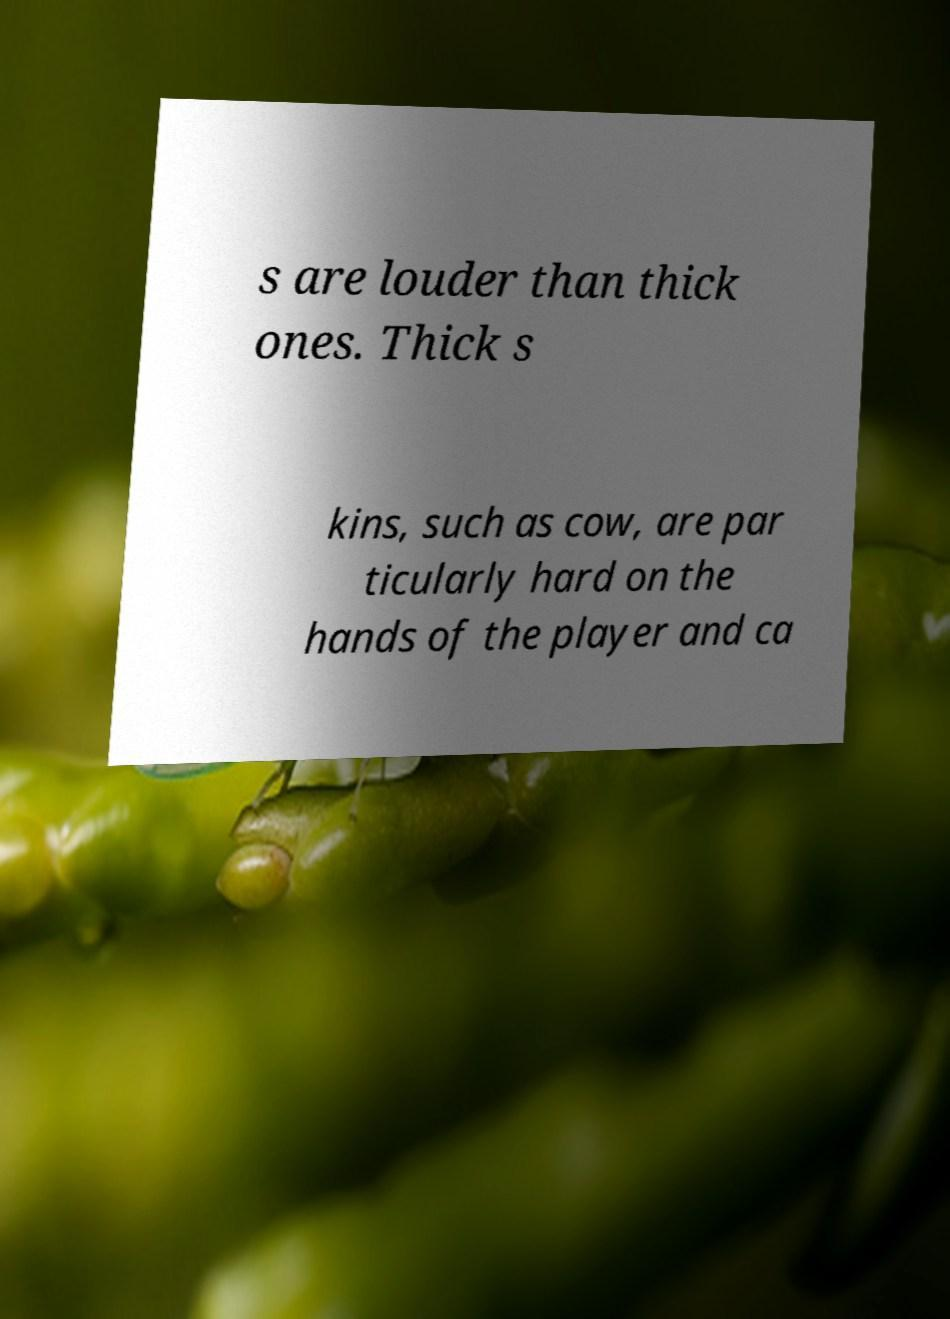Could you extract and type out the text from this image? s are louder than thick ones. Thick s kins, such as cow, are par ticularly hard on the hands of the player and ca 